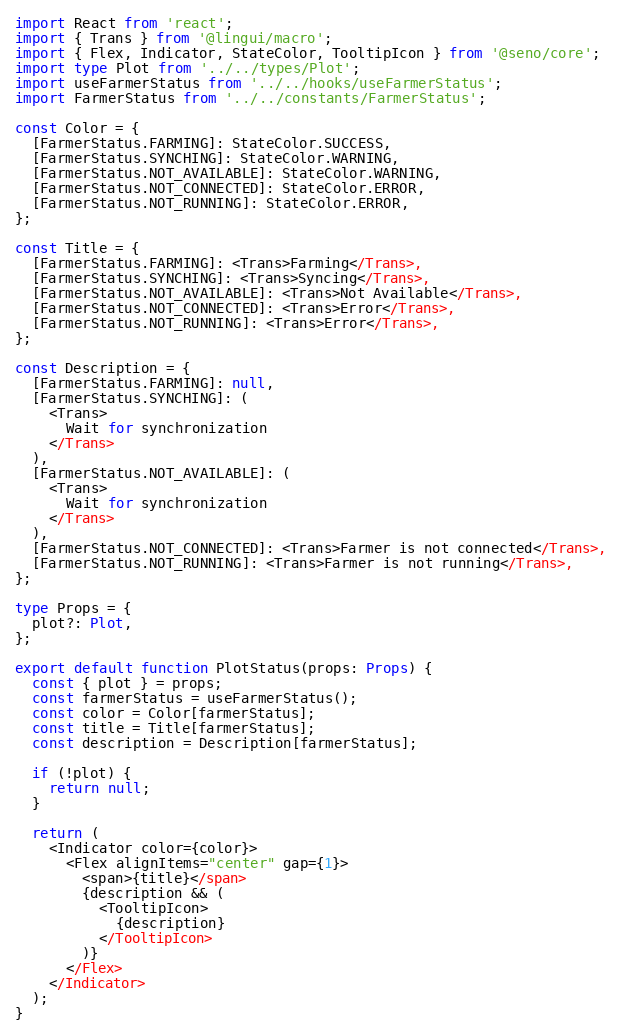Convert code to text. <code><loc_0><loc_0><loc_500><loc_500><_TypeScript_>import React from 'react';
import { Trans } from '@lingui/macro';
import { Flex, Indicator, StateColor, TooltipIcon } from '@seno/core';
import type Plot from '../../types/Plot';
import useFarmerStatus from '../../hooks/useFarmerStatus';
import FarmerStatus from '../../constants/FarmerStatus';

const Color = {
  [FarmerStatus.FARMING]: StateColor.SUCCESS,
  [FarmerStatus.SYNCHING]: StateColor.WARNING,
  [FarmerStatus.NOT_AVAILABLE]: StateColor.WARNING,
  [FarmerStatus.NOT_CONNECTED]: StateColor.ERROR,
  [FarmerStatus.NOT_RUNNING]: StateColor.ERROR,
};

const Title = {
  [FarmerStatus.FARMING]: <Trans>Farming</Trans>,
  [FarmerStatus.SYNCHING]: <Trans>Syncing</Trans>,
  [FarmerStatus.NOT_AVAILABLE]: <Trans>Not Available</Trans>,
  [FarmerStatus.NOT_CONNECTED]: <Trans>Error</Trans>,
  [FarmerStatus.NOT_RUNNING]: <Trans>Error</Trans>,
};

const Description = {
  [FarmerStatus.FARMING]: null,
  [FarmerStatus.SYNCHING]: (
    <Trans>
      Wait for synchronization
    </Trans>
  ),
  [FarmerStatus.NOT_AVAILABLE]: (
    <Trans>
      Wait for synchronization
    </Trans>
  ),
  [FarmerStatus.NOT_CONNECTED]: <Trans>Farmer is not connected</Trans>,
  [FarmerStatus.NOT_RUNNING]: <Trans>Farmer is not running</Trans>,
};

type Props = {
  plot?: Plot,
};

export default function PlotStatus(props: Props) {
  const { plot } = props;
  const farmerStatus = useFarmerStatus();
  const color = Color[farmerStatus];
  const title = Title[farmerStatus];
  const description = Description[farmerStatus];

  if (!plot) {
    return null;
  }

  return (
    <Indicator color={color}>
      <Flex alignItems="center" gap={1}>
        <span>{title}</span>
        {description && (
          <TooltipIcon>
            {description}
          </TooltipIcon>
        )}
      </Flex>
    </Indicator>
  );
}
</code> 